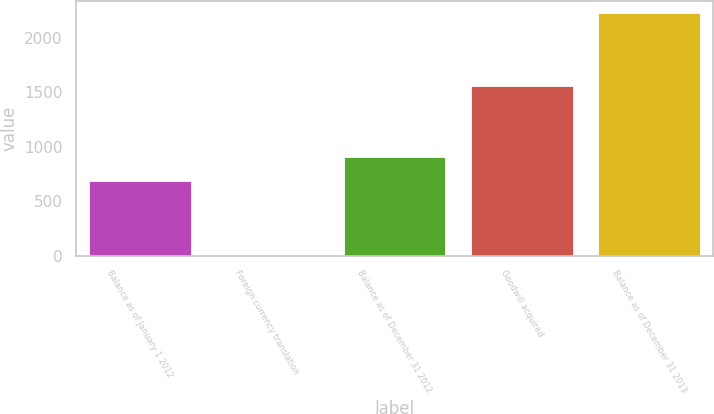Convert chart. <chart><loc_0><loc_0><loc_500><loc_500><bar_chart><fcel>Balance as of January 1 2012<fcel>Foreign currency translation<fcel>Balance as of December 31 2012<fcel>Goodwill acquired<fcel>Balance as of December 31 2013<nl><fcel>685<fcel>2<fcel>907.5<fcel>1559<fcel>2227<nl></chart> 